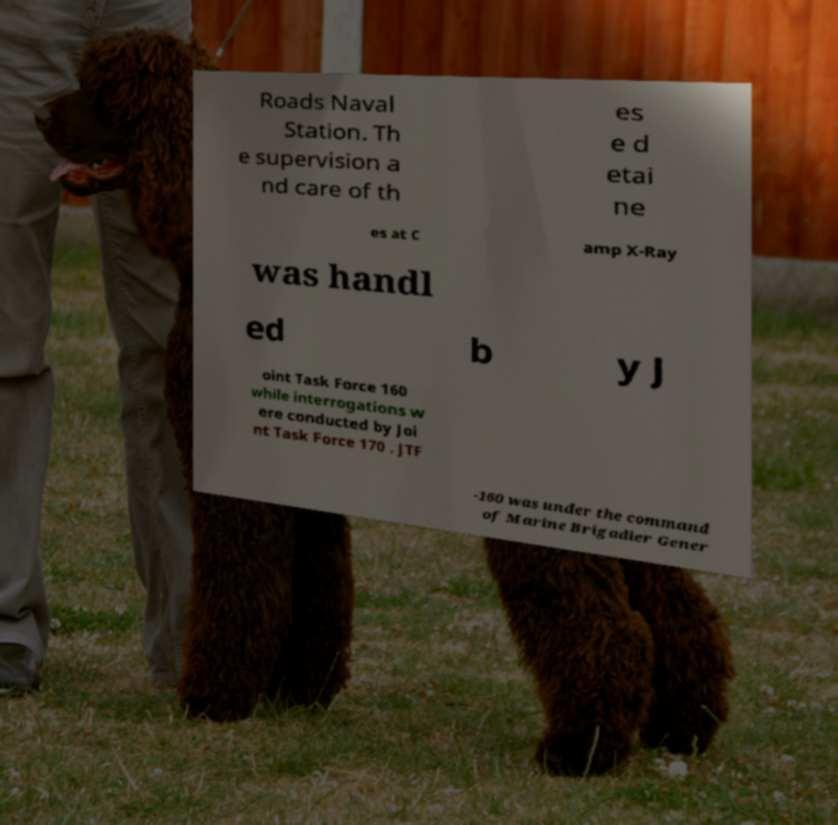There's text embedded in this image that I need extracted. Can you transcribe it verbatim? Roads Naval Station. Th e supervision a nd care of th es e d etai ne es at C amp X-Ray was handl ed b y J oint Task Force 160 while interrogations w ere conducted by Joi nt Task Force 170 . JTF -160 was under the command of Marine Brigadier Gener 